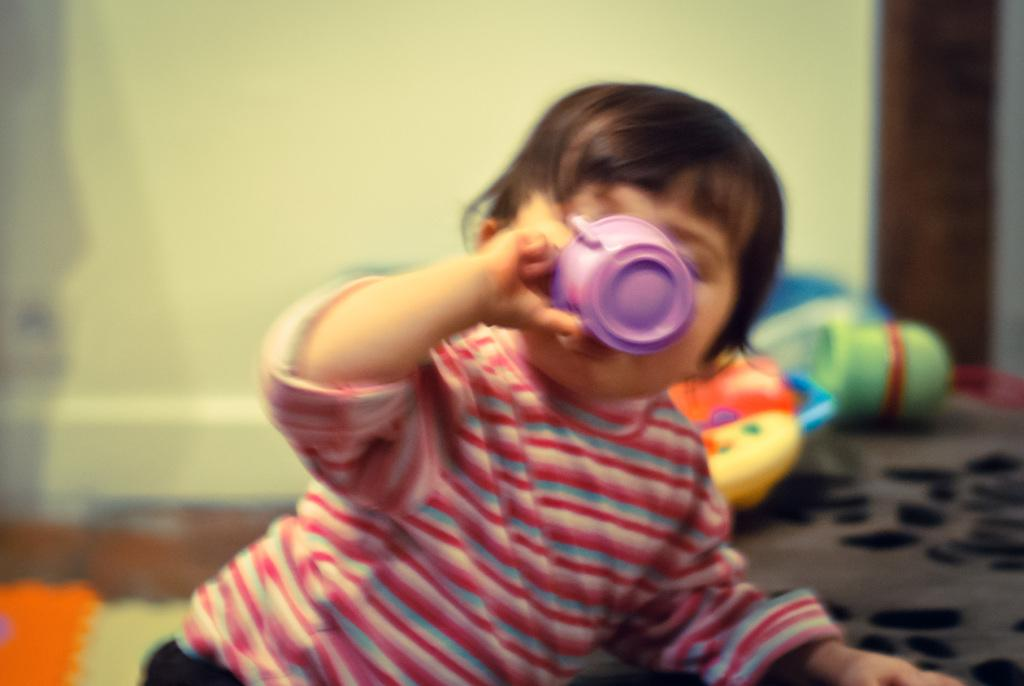What is the main subject of the image? The main subject of the image is a kid. What is the kid holding in the image? The kid is holding a cup with his hand. What else can be seen in the image besides the kid? There are toys in the image. Can you describe the background of the image? The background of the image is blurred. What type of club is the kid using to wash the toys in the image? There is no club or washing activity present in the image. 